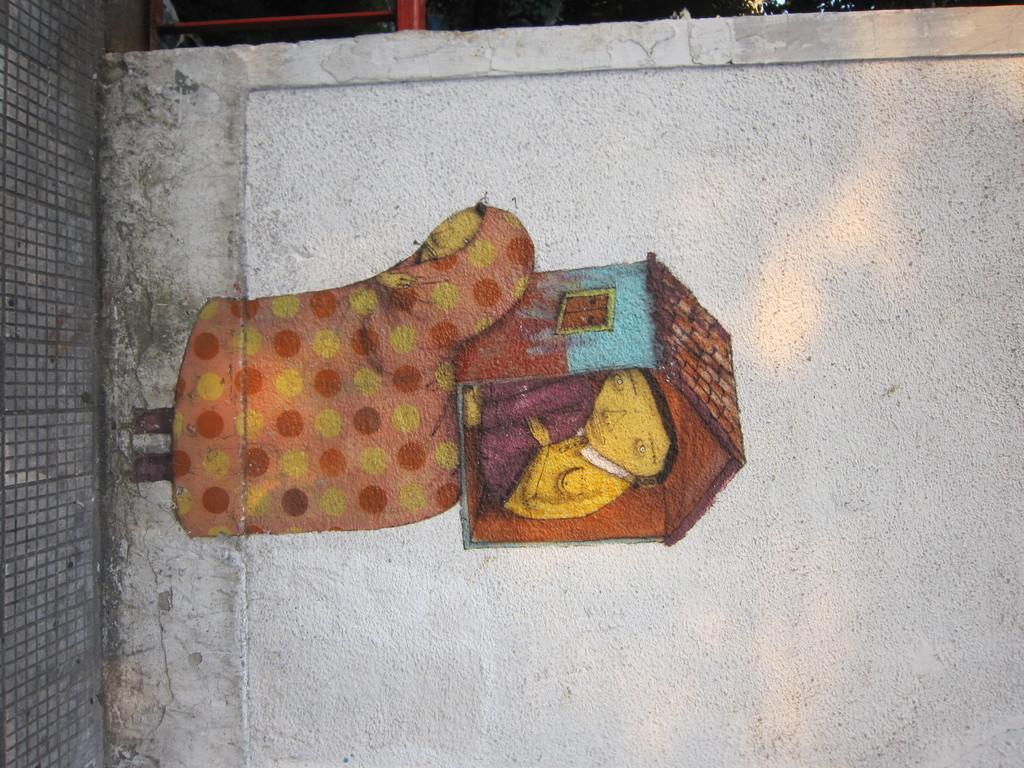Could you give a brief overview of what you see in this image? In the image we can see this is a wall and on the wall there is a painting, this is a street. 